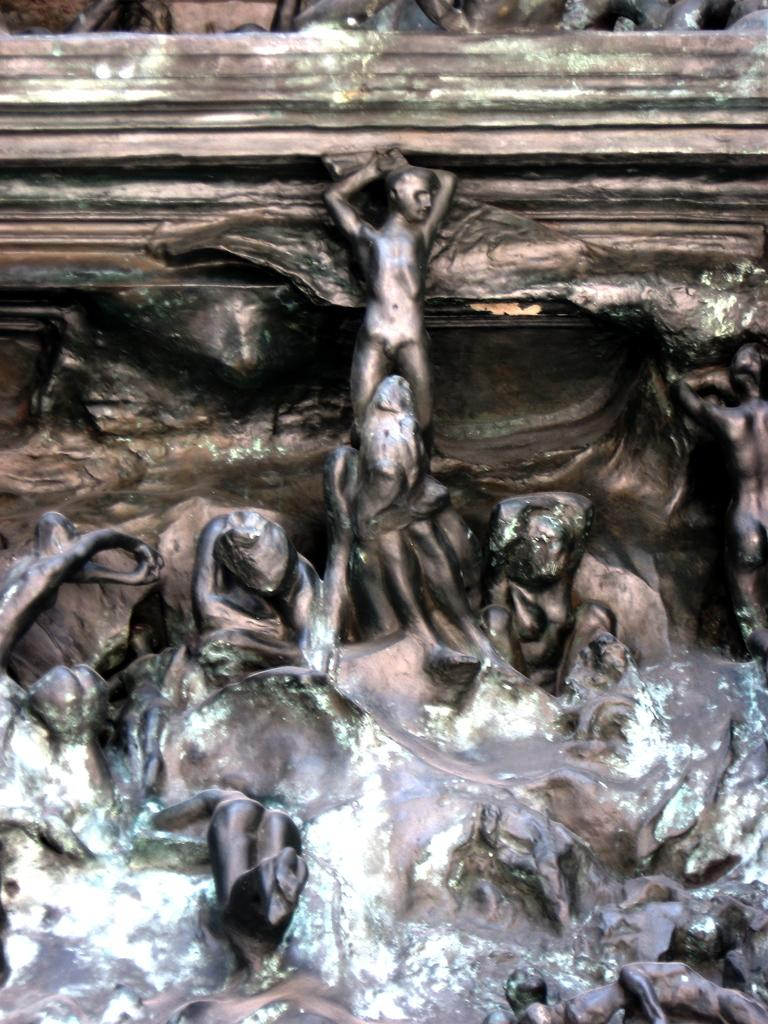What type of art can be seen in the image? The image contains wood carvings. What specific objects are carved from the wood? There are statues carved in the wood. How does the wood carving shake hands with the viewer in the image? The wood carving does not shake hands with the viewer in the image, as it is a static object. 